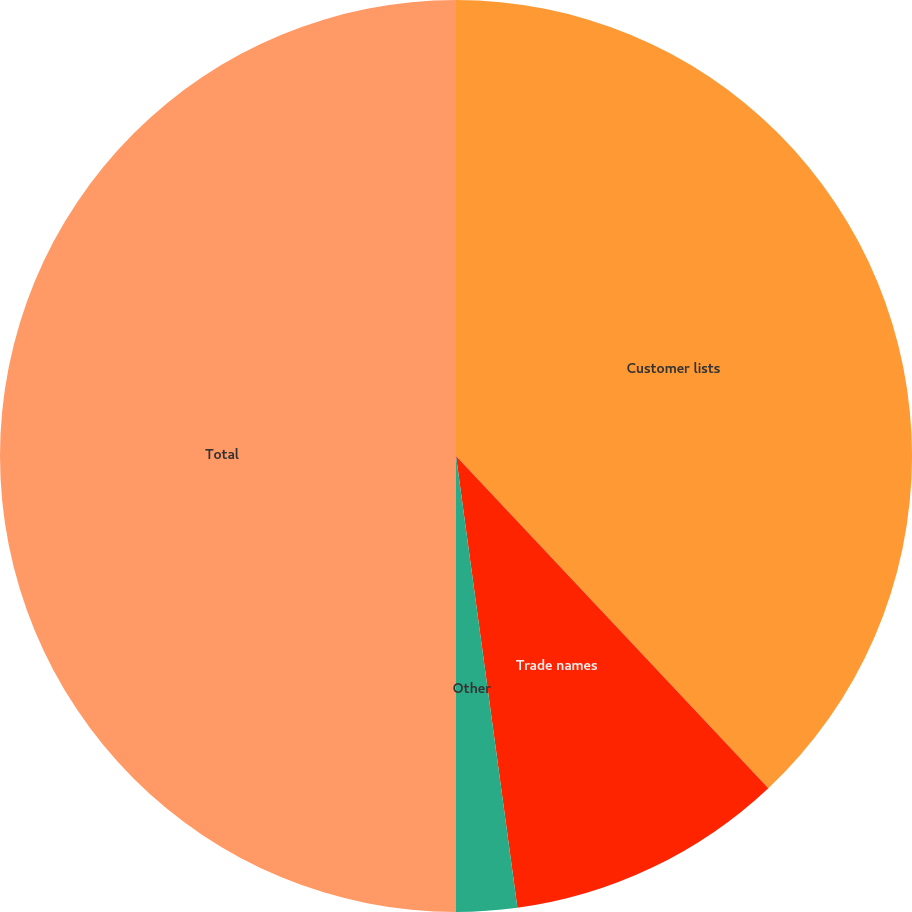Convert chart to OTSL. <chart><loc_0><loc_0><loc_500><loc_500><pie_chart><fcel>Customer lists<fcel>Trade names<fcel>Other<fcel>Total<nl><fcel>37.99%<fcel>9.86%<fcel>2.15%<fcel>50.0%<nl></chart> 